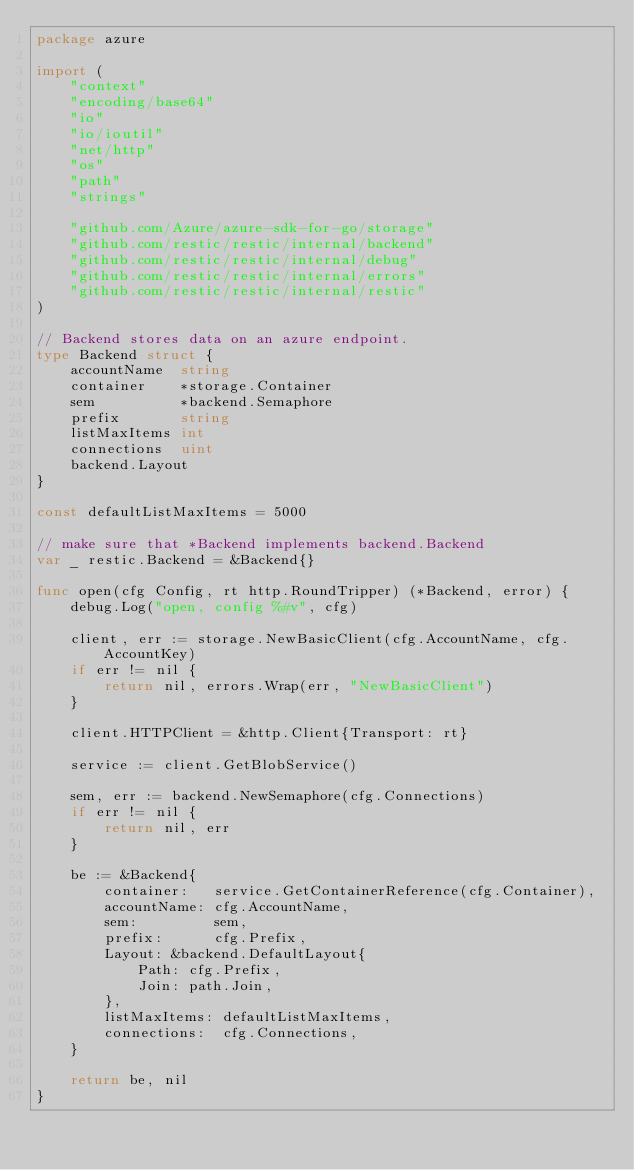Convert code to text. <code><loc_0><loc_0><loc_500><loc_500><_Go_>package azure

import (
	"context"
	"encoding/base64"
	"io"
	"io/ioutil"
	"net/http"
	"os"
	"path"
	"strings"

	"github.com/Azure/azure-sdk-for-go/storage"
	"github.com/restic/restic/internal/backend"
	"github.com/restic/restic/internal/debug"
	"github.com/restic/restic/internal/errors"
	"github.com/restic/restic/internal/restic"
)

// Backend stores data on an azure endpoint.
type Backend struct {
	accountName  string
	container    *storage.Container
	sem          *backend.Semaphore
	prefix       string
	listMaxItems int
	connections  uint
	backend.Layout
}

const defaultListMaxItems = 5000

// make sure that *Backend implements backend.Backend
var _ restic.Backend = &Backend{}

func open(cfg Config, rt http.RoundTripper) (*Backend, error) {
	debug.Log("open, config %#v", cfg)

	client, err := storage.NewBasicClient(cfg.AccountName, cfg.AccountKey)
	if err != nil {
		return nil, errors.Wrap(err, "NewBasicClient")
	}

	client.HTTPClient = &http.Client{Transport: rt}

	service := client.GetBlobService()

	sem, err := backend.NewSemaphore(cfg.Connections)
	if err != nil {
		return nil, err
	}

	be := &Backend{
		container:   service.GetContainerReference(cfg.Container),
		accountName: cfg.AccountName,
		sem:         sem,
		prefix:      cfg.Prefix,
		Layout: &backend.DefaultLayout{
			Path: cfg.Prefix,
			Join: path.Join,
		},
		listMaxItems: defaultListMaxItems,
		connections:  cfg.Connections,
	}

	return be, nil
}
</code> 